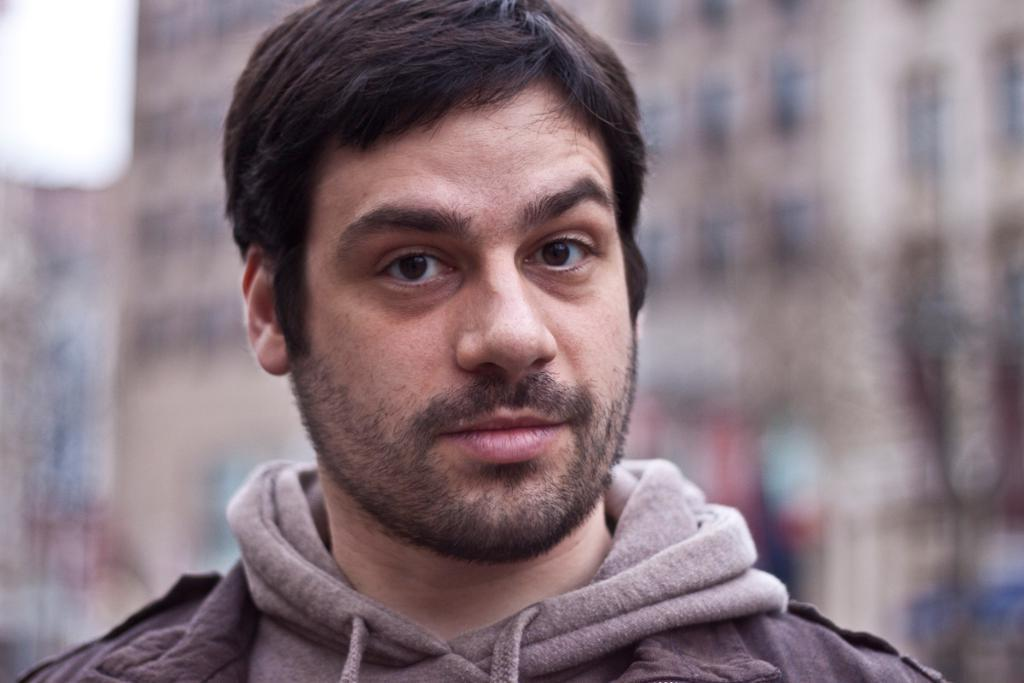Who is present in the image? There is a man in the image. Can you describe the background of the image? The background of the image is blurry. Reasoning: Let's think step by step by step in order to produce the conversation. We start by identifying the main subject in the image, which is the man. Then, we expand the conversation to include the background of the image, which is described as blurry. We avoid asking questions that cannot be answered definitively with the information given and ensure that the language is simple and clear. Absurd Question/Answer: What type of test is the frog taking in the image? There is no frog present in the image, and therefore no test can be observed. 